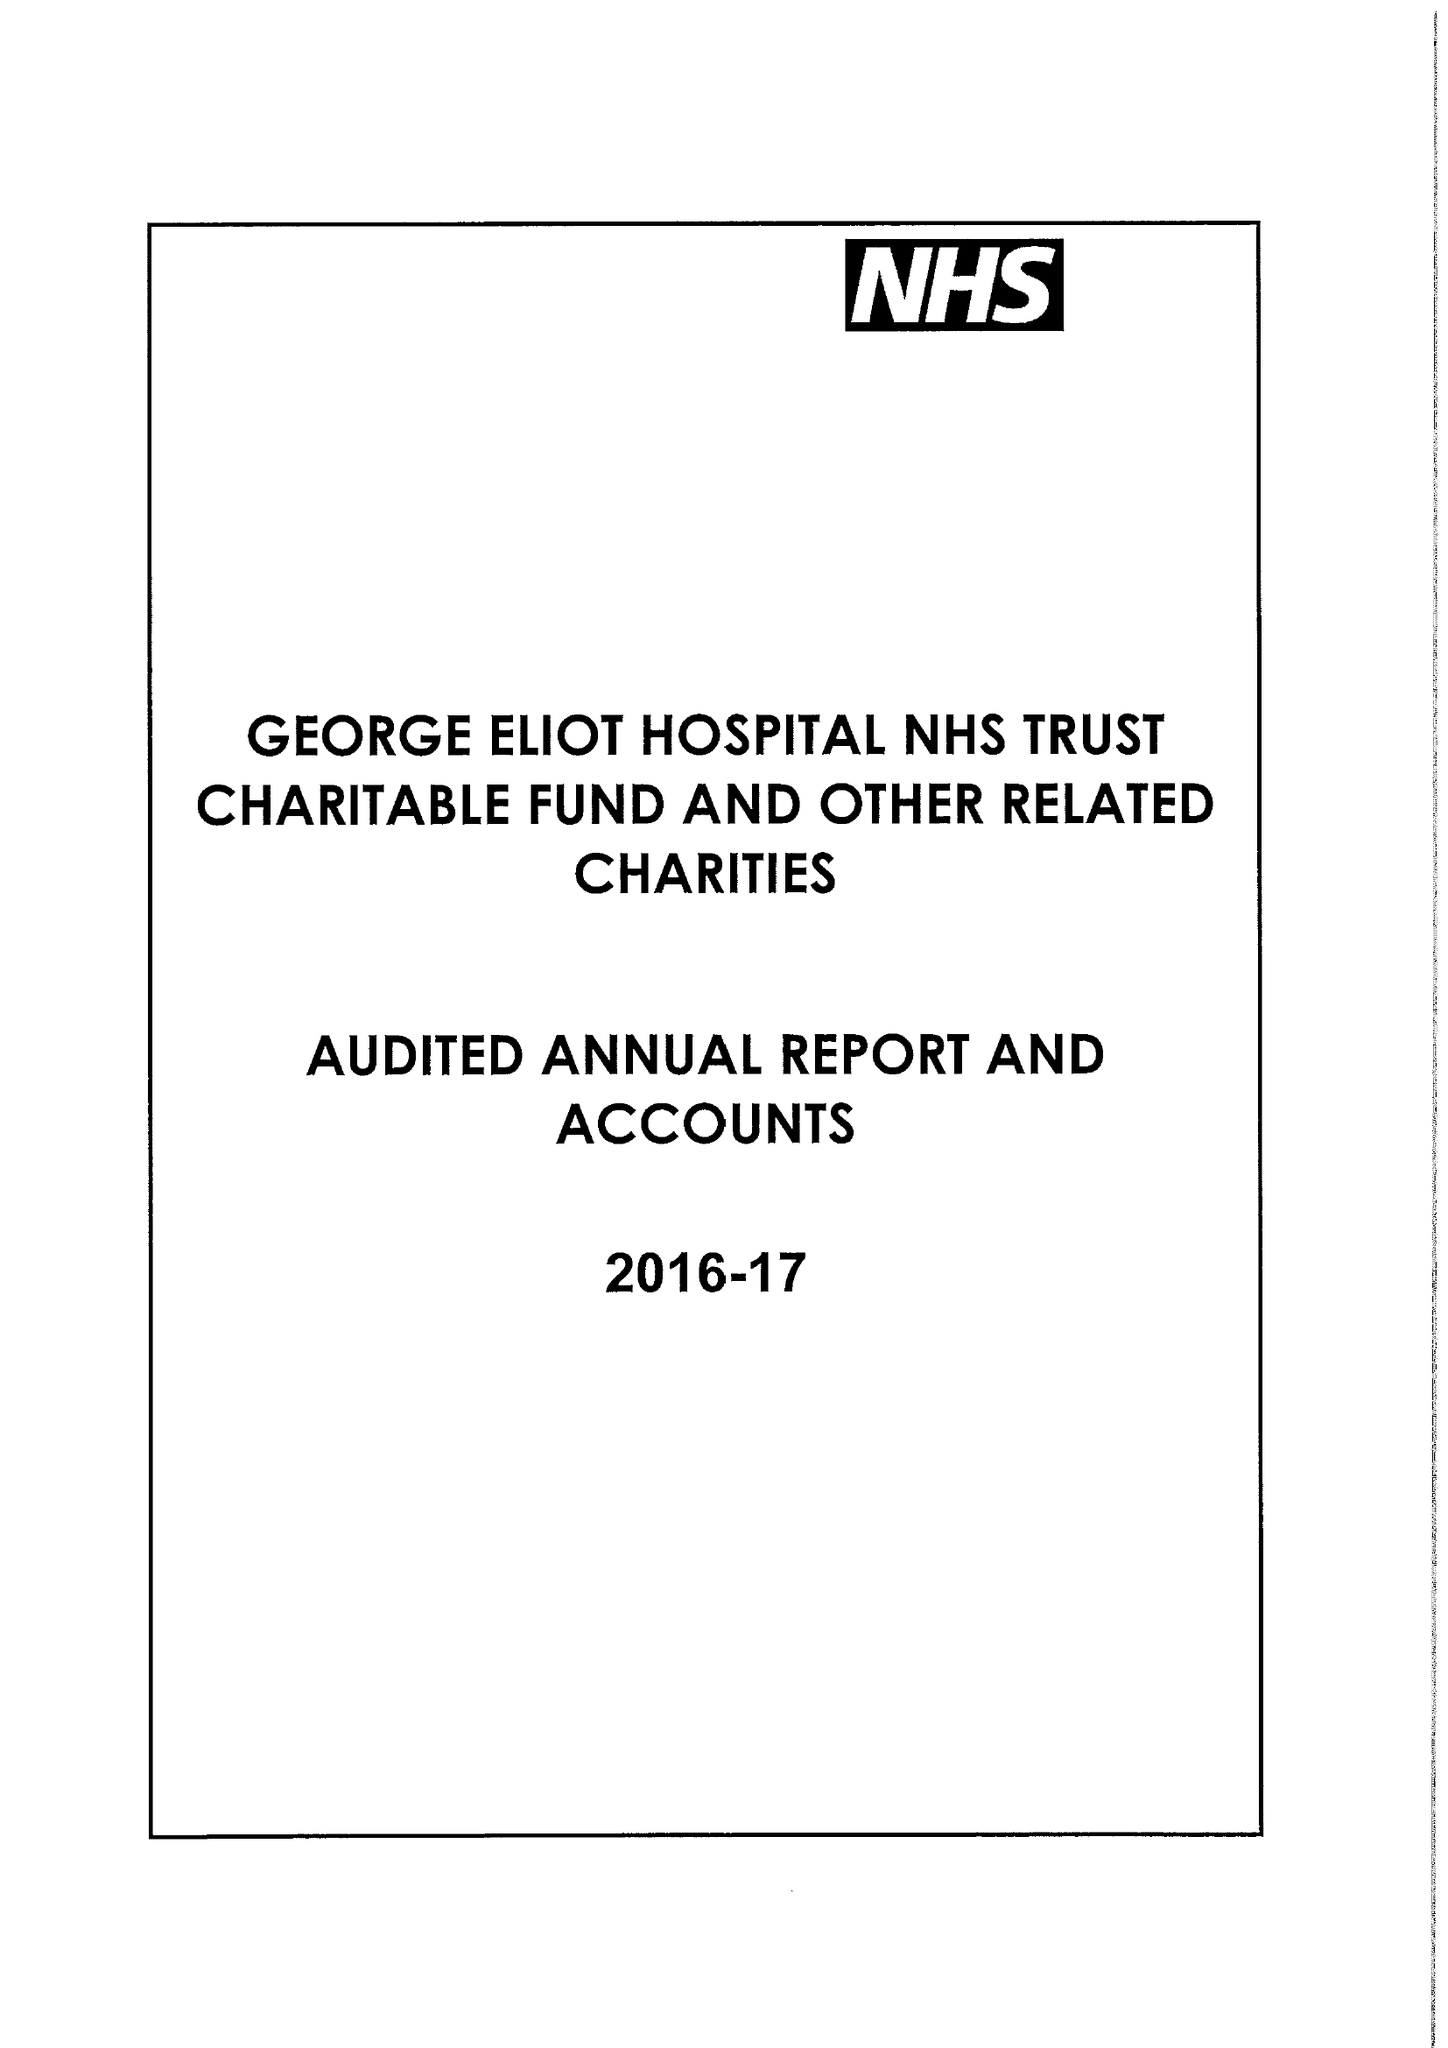What is the value for the report_date?
Answer the question using a single word or phrase. 2017-03-31 